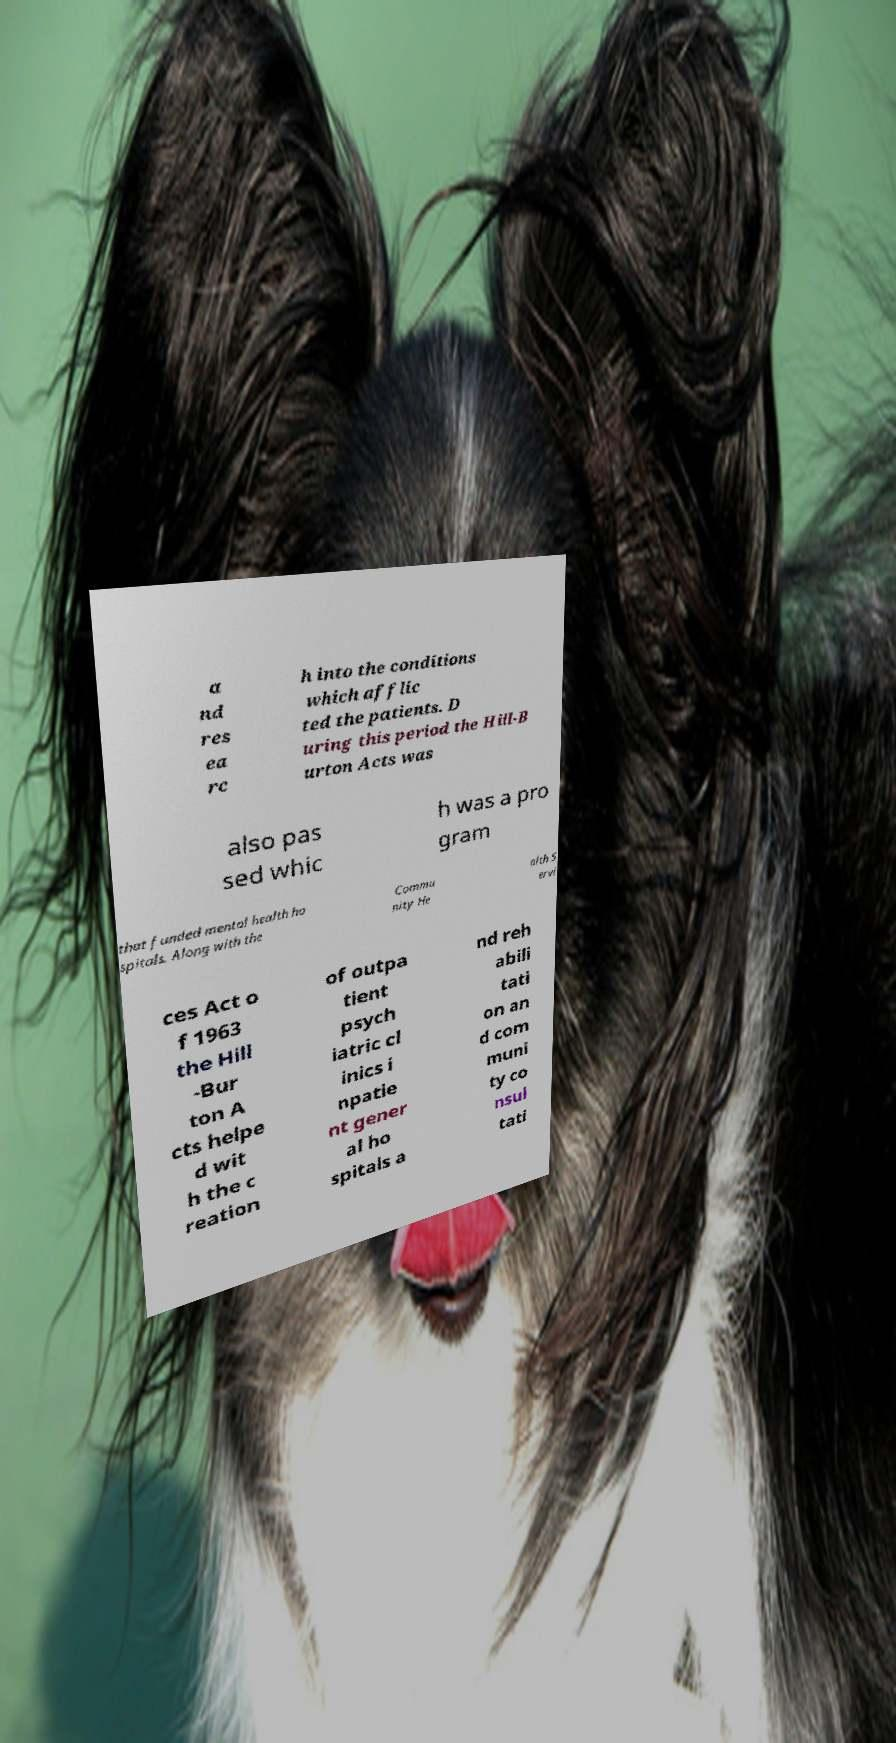There's text embedded in this image that I need extracted. Can you transcribe it verbatim? a nd res ea rc h into the conditions which afflic ted the patients. D uring this period the Hill-B urton Acts was also pas sed whic h was a pro gram that funded mental health ho spitals. Along with the Commu nity He alth S ervi ces Act o f 1963 the Hill -Bur ton A cts helpe d wit h the c reation of outpa tient psych iatric cl inics i npatie nt gener al ho spitals a nd reh abili tati on an d com muni ty co nsul tati 